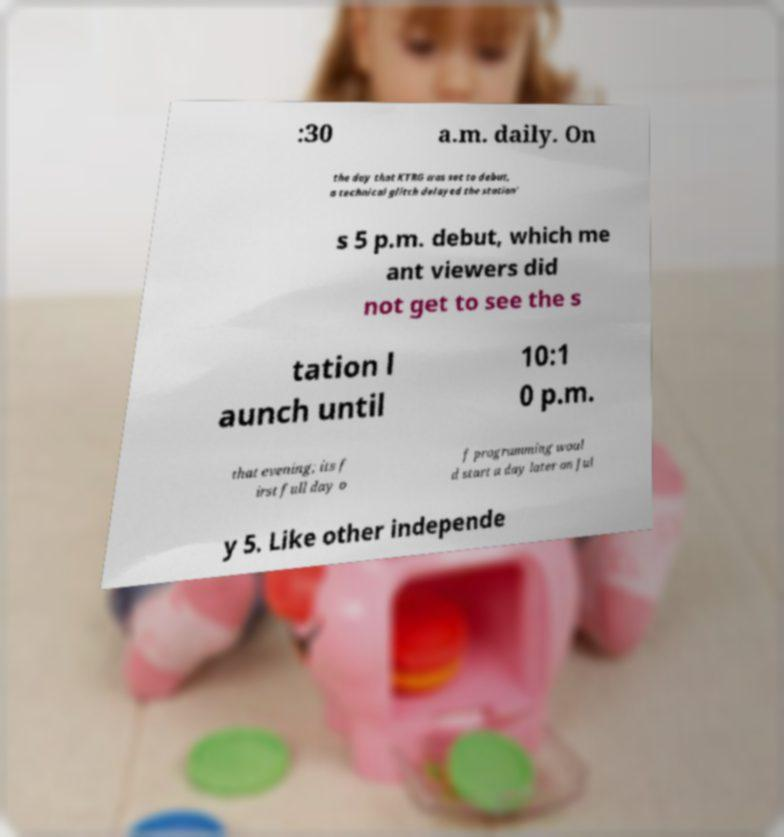Please read and relay the text visible in this image. What does it say? :30 a.m. daily. On the day that KTRG was set to debut, a technical glitch delayed the station' s 5 p.m. debut, which me ant viewers did not get to see the s tation l aunch until 10:1 0 p.m. that evening; its f irst full day o f programming woul d start a day later on Jul y 5. Like other independe 